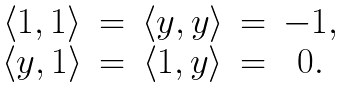Convert formula to latex. <formula><loc_0><loc_0><loc_500><loc_500>\begin{array} { c c c c c } \langle 1 , 1 \rangle & = & \langle y , y \rangle & = & - 1 , \\ \langle y , 1 \rangle & = & \langle 1 , y \rangle & = & 0 . \\ \end{array}</formula> 